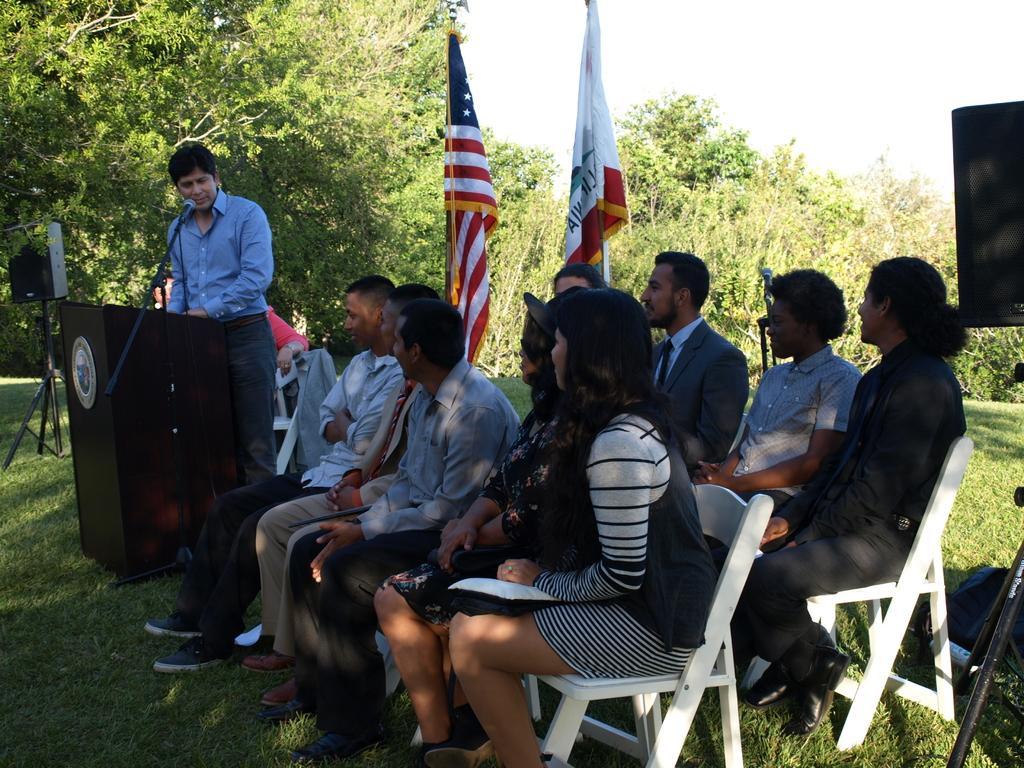How would you summarize this image in a sentence or two? A group of people are sitting and listening to a man whose is standing at a podium and speaking. 